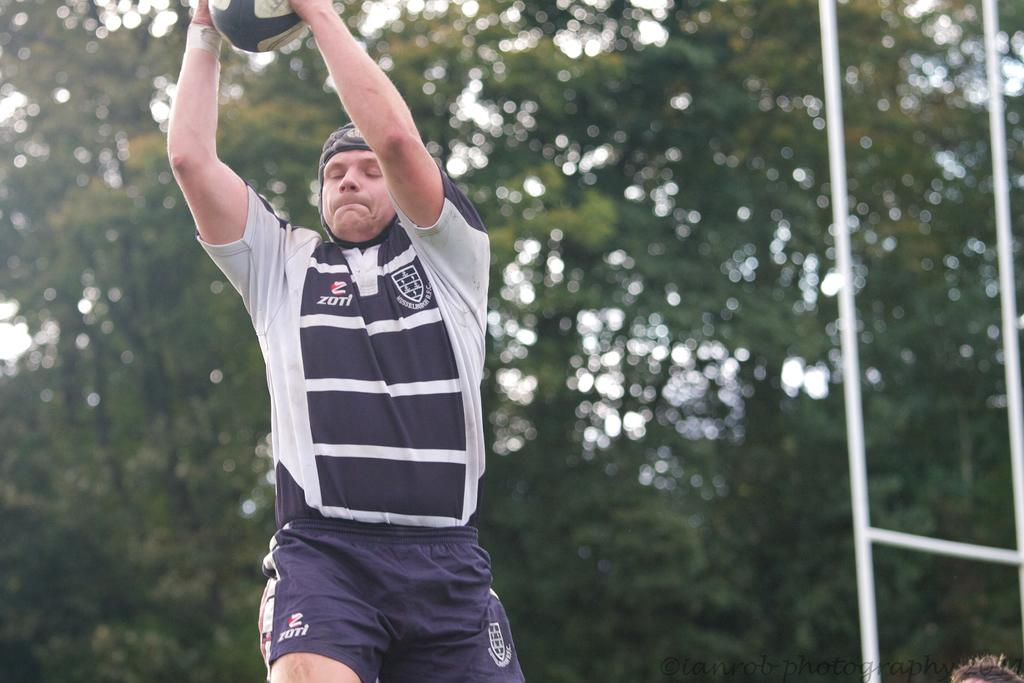<image>
Summarize the visual content of the image. A man in a shirt that says zotl catches a rugby ball. 